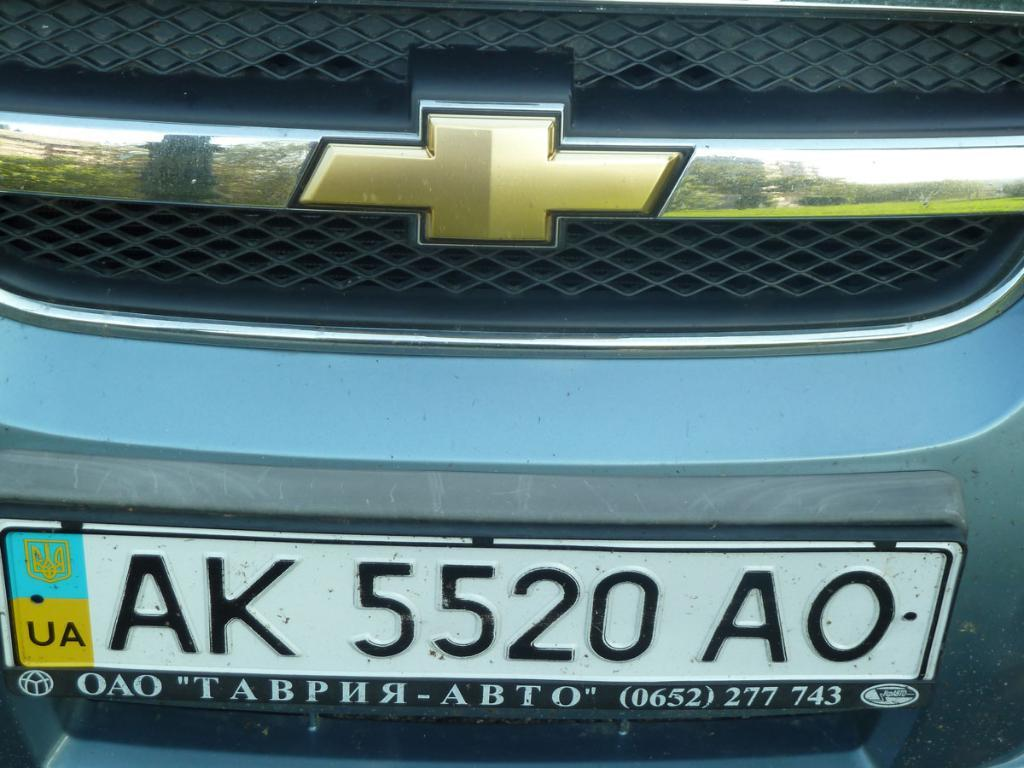<image>
Provide a brief description of the given image. the letters AK start off the license plate 